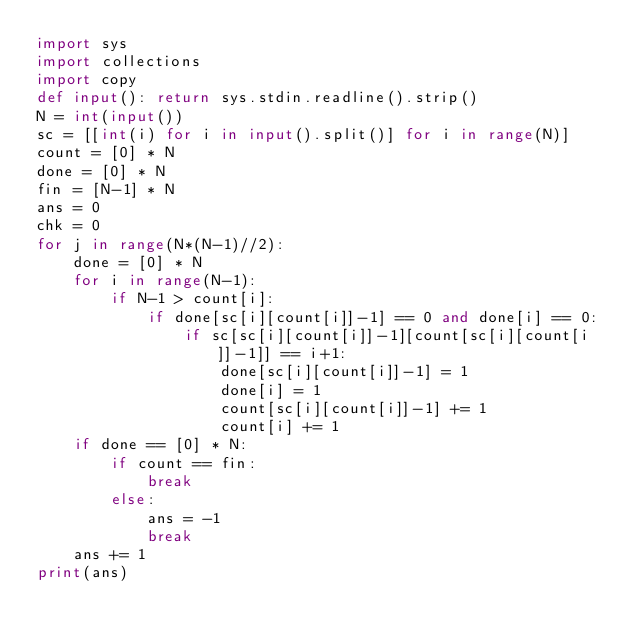Convert code to text. <code><loc_0><loc_0><loc_500><loc_500><_Python_>import sys
import collections
import copy
def input(): return sys.stdin.readline().strip()
N = int(input())
sc = [[int(i) for i in input().split()] for i in range(N)]
count = [0] * N
done = [0] * N
fin = [N-1] * N
ans = 0
chk = 0
for j in range(N*(N-1)//2):
    done = [0] * N
    for i in range(N-1):
        if N-1 > count[i]:
            if done[sc[i][count[i]]-1] == 0 and done[i] == 0:
                if sc[sc[i][count[i]]-1][count[sc[i][count[i]]-1]] == i+1:
                    done[sc[i][count[i]]-1] = 1
                    done[i] = 1
                    count[sc[i][count[i]]-1] += 1
                    count[i] += 1
    if done == [0] * N:
        if count == fin:
            break
        else:
            ans = -1
            break
    ans += 1
print(ans)</code> 